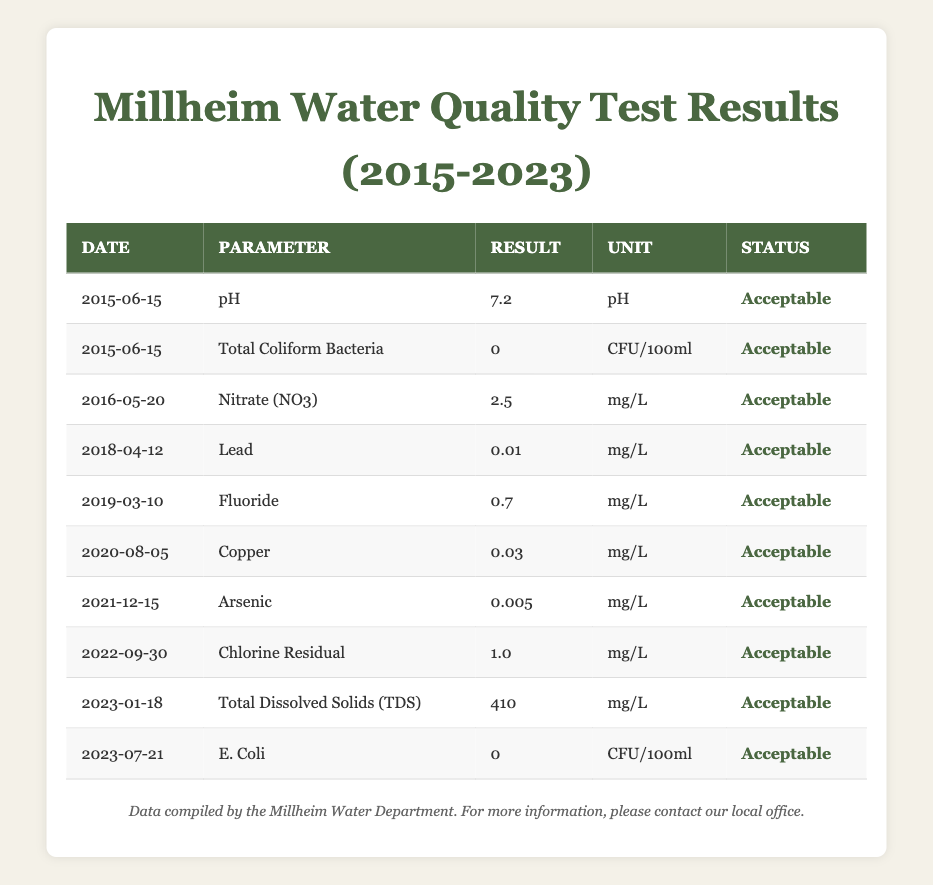What is the acceptable level of pH based on the tests conducted? The table shows that pH was tested on June 15, 2015, yielding a result of 7.2, marked as acceptable. Therefore, the acceptable level of pH in the water tested is 7.2 pH.
Answer: 7.2 pH When was the last test conducted for Total Dissolved Solids (TDS)? The table indicates that Total Dissolved Solids (TDS) were tested on January 18, 2023. This marks the most recent test for this parameter.
Answer: January 18, 2023 Is there any instance of total coliform bacteria found in the water supply tests? Looking at the row for Total Coliform Bacteria on June 15, 2015, it shows a result of 0 CFU/100ml, which indicates that there were no coliform bacteria detected in that test. Therefore, there is no instance of total coliform bacteria found in the water supply.
Answer: No What was the highest result recorded for any of the parameters from 2015 to 2023? To find the highest result, we need to compare the results across all parameters. The highest recorded result is for Total Dissolved Solids (TDS) on January 18, 2023, at 410 mg/L, as it is greater than all other values listed in the table.
Answer: 410 mg/L How many water quality tests were conducted that returned an acceptable result? Each row in the table indicates that the corresponding test result was acceptable. There are 10 entries in the table, meaning there were 10 tests conducted, all returning an acceptable result.
Answer: 10 